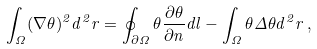<formula> <loc_0><loc_0><loc_500><loc_500>\int _ { \Omega } ( \nabla \theta ) ^ { 2 } d ^ { 2 } { r } = \oint _ { \partial \Omega } \theta \frac { \partial \theta } { \partial { n } } d { l } - \int _ { \Omega } \theta \Delta \theta d ^ { 2 } { r } \, ,</formula> 